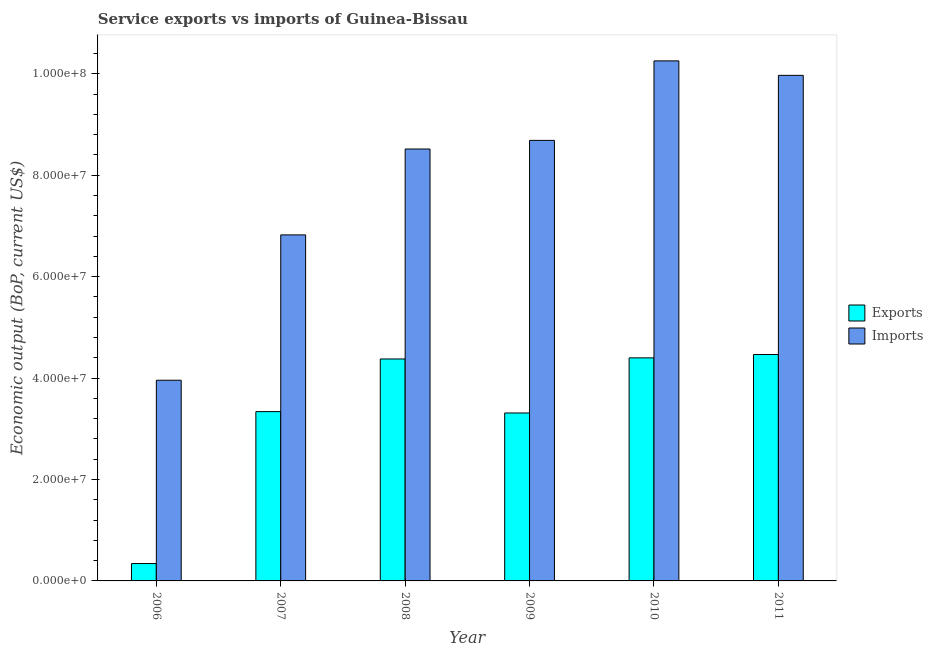How many different coloured bars are there?
Provide a short and direct response. 2. Are the number of bars per tick equal to the number of legend labels?
Ensure brevity in your answer.  Yes. Are the number of bars on each tick of the X-axis equal?
Provide a short and direct response. Yes. How many bars are there on the 5th tick from the left?
Make the answer very short. 2. What is the label of the 4th group of bars from the left?
Ensure brevity in your answer.  2009. In how many cases, is the number of bars for a given year not equal to the number of legend labels?
Your answer should be very brief. 0. What is the amount of service imports in 2008?
Offer a terse response. 8.52e+07. Across all years, what is the maximum amount of service exports?
Provide a short and direct response. 4.46e+07. Across all years, what is the minimum amount of service imports?
Give a very brief answer. 3.96e+07. In which year was the amount of service exports maximum?
Give a very brief answer. 2011. What is the total amount of service exports in the graph?
Offer a terse response. 2.02e+08. What is the difference between the amount of service exports in 2007 and that in 2011?
Offer a terse response. -1.13e+07. What is the difference between the amount of service exports in 2008 and the amount of service imports in 2007?
Your answer should be compact. 1.04e+07. What is the average amount of service imports per year?
Offer a terse response. 8.04e+07. What is the ratio of the amount of service imports in 2007 to that in 2010?
Give a very brief answer. 0.67. Is the amount of service imports in 2006 less than that in 2007?
Make the answer very short. Yes. What is the difference between the highest and the second highest amount of service imports?
Offer a very short reply. 2.86e+06. What is the difference between the highest and the lowest amount of service exports?
Your answer should be very brief. 4.12e+07. In how many years, is the amount of service exports greater than the average amount of service exports taken over all years?
Your answer should be very brief. 3. What does the 1st bar from the left in 2006 represents?
Offer a very short reply. Exports. What does the 1st bar from the right in 2009 represents?
Provide a short and direct response. Imports. Are all the bars in the graph horizontal?
Keep it short and to the point. No. What is the difference between two consecutive major ticks on the Y-axis?
Give a very brief answer. 2.00e+07. Does the graph contain any zero values?
Your response must be concise. No. How many legend labels are there?
Offer a terse response. 2. How are the legend labels stacked?
Your answer should be compact. Vertical. What is the title of the graph?
Provide a short and direct response. Service exports vs imports of Guinea-Bissau. What is the label or title of the X-axis?
Keep it short and to the point. Year. What is the label or title of the Y-axis?
Make the answer very short. Economic output (BoP, current US$). What is the Economic output (BoP, current US$) in Exports in 2006?
Your answer should be compact. 3.43e+06. What is the Economic output (BoP, current US$) of Imports in 2006?
Offer a very short reply. 3.96e+07. What is the Economic output (BoP, current US$) of Exports in 2007?
Your response must be concise. 3.34e+07. What is the Economic output (BoP, current US$) of Imports in 2007?
Ensure brevity in your answer.  6.82e+07. What is the Economic output (BoP, current US$) of Exports in 2008?
Make the answer very short. 4.38e+07. What is the Economic output (BoP, current US$) of Imports in 2008?
Provide a short and direct response. 8.52e+07. What is the Economic output (BoP, current US$) in Exports in 2009?
Your response must be concise. 3.31e+07. What is the Economic output (BoP, current US$) in Imports in 2009?
Make the answer very short. 8.69e+07. What is the Economic output (BoP, current US$) in Exports in 2010?
Offer a very short reply. 4.40e+07. What is the Economic output (BoP, current US$) of Imports in 2010?
Provide a succinct answer. 1.03e+08. What is the Economic output (BoP, current US$) of Exports in 2011?
Give a very brief answer. 4.46e+07. What is the Economic output (BoP, current US$) in Imports in 2011?
Offer a terse response. 9.97e+07. Across all years, what is the maximum Economic output (BoP, current US$) in Exports?
Give a very brief answer. 4.46e+07. Across all years, what is the maximum Economic output (BoP, current US$) in Imports?
Your response must be concise. 1.03e+08. Across all years, what is the minimum Economic output (BoP, current US$) in Exports?
Keep it short and to the point. 3.43e+06. Across all years, what is the minimum Economic output (BoP, current US$) of Imports?
Make the answer very short. 3.96e+07. What is the total Economic output (BoP, current US$) of Exports in the graph?
Your answer should be compact. 2.02e+08. What is the total Economic output (BoP, current US$) in Imports in the graph?
Your answer should be compact. 4.82e+08. What is the difference between the Economic output (BoP, current US$) of Exports in 2006 and that in 2007?
Your response must be concise. -3.00e+07. What is the difference between the Economic output (BoP, current US$) of Imports in 2006 and that in 2007?
Offer a terse response. -2.87e+07. What is the difference between the Economic output (BoP, current US$) in Exports in 2006 and that in 2008?
Offer a very short reply. -4.03e+07. What is the difference between the Economic output (BoP, current US$) in Imports in 2006 and that in 2008?
Ensure brevity in your answer.  -4.56e+07. What is the difference between the Economic output (BoP, current US$) in Exports in 2006 and that in 2009?
Your answer should be compact. -2.97e+07. What is the difference between the Economic output (BoP, current US$) in Imports in 2006 and that in 2009?
Ensure brevity in your answer.  -4.73e+07. What is the difference between the Economic output (BoP, current US$) in Exports in 2006 and that in 2010?
Provide a succinct answer. -4.06e+07. What is the difference between the Economic output (BoP, current US$) of Imports in 2006 and that in 2010?
Make the answer very short. -6.30e+07. What is the difference between the Economic output (BoP, current US$) in Exports in 2006 and that in 2011?
Offer a very short reply. -4.12e+07. What is the difference between the Economic output (BoP, current US$) of Imports in 2006 and that in 2011?
Give a very brief answer. -6.01e+07. What is the difference between the Economic output (BoP, current US$) of Exports in 2007 and that in 2008?
Offer a terse response. -1.04e+07. What is the difference between the Economic output (BoP, current US$) in Imports in 2007 and that in 2008?
Offer a very short reply. -1.69e+07. What is the difference between the Economic output (BoP, current US$) in Exports in 2007 and that in 2009?
Your answer should be compact. 2.70e+05. What is the difference between the Economic output (BoP, current US$) in Imports in 2007 and that in 2009?
Offer a terse response. -1.86e+07. What is the difference between the Economic output (BoP, current US$) in Exports in 2007 and that in 2010?
Ensure brevity in your answer.  -1.06e+07. What is the difference between the Economic output (BoP, current US$) in Imports in 2007 and that in 2010?
Your answer should be very brief. -3.43e+07. What is the difference between the Economic output (BoP, current US$) in Exports in 2007 and that in 2011?
Offer a terse response. -1.13e+07. What is the difference between the Economic output (BoP, current US$) of Imports in 2007 and that in 2011?
Offer a very short reply. -3.15e+07. What is the difference between the Economic output (BoP, current US$) in Exports in 2008 and that in 2009?
Offer a very short reply. 1.07e+07. What is the difference between the Economic output (BoP, current US$) in Imports in 2008 and that in 2009?
Ensure brevity in your answer.  -1.70e+06. What is the difference between the Economic output (BoP, current US$) in Exports in 2008 and that in 2010?
Your answer should be compact. -2.20e+05. What is the difference between the Economic output (BoP, current US$) of Imports in 2008 and that in 2010?
Offer a terse response. -1.74e+07. What is the difference between the Economic output (BoP, current US$) of Exports in 2008 and that in 2011?
Offer a very short reply. -8.79e+05. What is the difference between the Economic output (BoP, current US$) of Imports in 2008 and that in 2011?
Provide a succinct answer. -1.45e+07. What is the difference between the Economic output (BoP, current US$) of Exports in 2009 and that in 2010?
Provide a succinct answer. -1.09e+07. What is the difference between the Economic output (BoP, current US$) in Imports in 2009 and that in 2010?
Make the answer very short. -1.57e+07. What is the difference between the Economic output (BoP, current US$) of Exports in 2009 and that in 2011?
Provide a short and direct response. -1.15e+07. What is the difference between the Economic output (BoP, current US$) of Imports in 2009 and that in 2011?
Your response must be concise. -1.28e+07. What is the difference between the Economic output (BoP, current US$) of Exports in 2010 and that in 2011?
Give a very brief answer. -6.59e+05. What is the difference between the Economic output (BoP, current US$) of Imports in 2010 and that in 2011?
Ensure brevity in your answer.  2.86e+06. What is the difference between the Economic output (BoP, current US$) of Exports in 2006 and the Economic output (BoP, current US$) of Imports in 2007?
Make the answer very short. -6.48e+07. What is the difference between the Economic output (BoP, current US$) of Exports in 2006 and the Economic output (BoP, current US$) of Imports in 2008?
Your answer should be very brief. -8.18e+07. What is the difference between the Economic output (BoP, current US$) of Exports in 2006 and the Economic output (BoP, current US$) of Imports in 2009?
Your response must be concise. -8.35e+07. What is the difference between the Economic output (BoP, current US$) of Exports in 2006 and the Economic output (BoP, current US$) of Imports in 2010?
Offer a very short reply. -9.91e+07. What is the difference between the Economic output (BoP, current US$) in Exports in 2006 and the Economic output (BoP, current US$) in Imports in 2011?
Offer a terse response. -9.63e+07. What is the difference between the Economic output (BoP, current US$) in Exports in 2007 and the Economic output (BoP, current US$) in Imports in 2008?
Offer a very short reply. -5.18e+07. What is the difference between the Economic output (BoP, current US$) in Exports in 2007 and the Economic output (BoP, current US$) in Imports in 2009?
Your response must be concise. -5.35e+07. What is the difference between the Economic output (BoP, current US$) in Exports in 2007 and the Economic output (BoP, current US$) in Imports in 2010?
Provide a short and direct response. -6.92e+07. What is the difference between the Economic output (BoP, current US$) in Exports in 2007 and the Economic output (BoP, current US$) in Imports in 2011?
Make the answer very short. -6.63e+07. What is the difference between the Economic output (BoP, current US$) of Exports in 2008 and the Economic output (BoP, current US$) of Imports in 2009?
Offer a very short reply. -4.31e+07. What is the difference between the Economic output (BoP, current US$) of Exports in 2008 and the Economic output (BoP, current US$) of Imports in 2010?
Provide a succinct answer. -5.88e+07. What is the difference between the Economic output (BoP, current US$) of Exports in 2008 and the Economic output (BoP, current US$) of Imports in 2011?
Offer a very short reply. -5.59e+07. What is the difference between the Economic output (BoP, current US$) in Exports in 2009 and the Economic output (BoP, current US$) in Imports in 2010?
Your answer should be very brief. -6.94e+07. What is the difference between the Economic output (BoP, current US$) of Exports in 2009 and the Economic output (BoP, current US$) of Imports in 2011?
Your answer should be compact. -6.66e+07. What is the difference between the Economic output (BoP, current US$) in Exports in 2010 and the Economic output (BoP, current US$) in Imports in 2011?
Your answer should be compact. -5.57e+07. What is the average Economic output (BoP, current US$) of Exports per year?
Offer a very short reply. 3.37e+07. What is the average Economic output (BoP, current US$) of Imports per year?
Provide a succinct answer. 8.04e+07. In the year 2006, what is the difference between the Economic output (BoP, current US$) in Exports and Economic output (BoP, current US$) in Imports?
Ensure brevity in your answer.  -3.62e+07. In the year 2007, what is the difference between the Economic output (BoP, current US$) in Exports and Economic output (BoP, current US$) in Imports?
Your response must be concise. -3.49e+07. In the year 2008, what is the difference between the Economic output (BoP, current US$) of Exports and Economic output (BoP, current US$) of Imports?
Keep it short and to the point. -4.14e+07. In the year 2009, what is the difference between the Economic output (BoP, current US$) of Exports and Economic output (BoP, current US$) of Imports?
Offer a very short reply. -5.38e+07. In the year 2010, what is the difference between the Economic output (BoP, current US$) of Exports and Economic output (BoP, current US$) of Imports?
Offer a very short reply. -5.86e+07. In the year 2011, what is the difference between the Economic output (BoP, current US$) in Exports and Economic output (BoP, current US$) in Imports?
Offer a terse response. -5.51e+07. What is the ratio of the Economic output (BoP, current US$) in Exports in 2006 to that in 2007?
Your answer should be compact. 0.1. What is the ratio of the Economic output (BoP, current US$) of Imports in 2006 to that in 2007?
Ensure brevity in your answer.  0.58. What is the ratio of the Economic output (BoP, current US$) in Exports in 2006 to that in 2008?
Provide a succinct answer. 0.08. What is the ratio of the Economic output (BoP, current US$) of Imports in 2006 to that in 2008?
Provide a short and direct response. 0.46. What is the ratio of the Economic output (BoP, current US$) in Exports in 2006 to that in 2009?
Offer a terse response. 0.1. What is the ratio of the Economic output (BoP, current US$) of Imports in 2006 to that in 2009?
Provide a short and direct response. 0.46. What is the ratio of the Economic output (BoP, current US$) of Exports in 2006 to that in 2010?
Provide a succinct answer. 0.08. What is the ratio of the Economic output (BoP, current US$) in Imports in 2006 to that in 2010?
Your answer should be compact. 0.39. What is the ratio of the Economic output (BoP, current US$) in Exports in 2006 to that in 2011?
Provide a succinct answer. 0.08. What is the ratio of the Economic output (BoP, current US$) of Imports in 2006 to that in 2011?
Your answer should be compact. 0.4. What is the ratio of the Economic output (BoP, current US$) in Exports in 2007 to that in 2008?
Offer a very short reply. 0.76. What is the ratio of the Economic output (BoP, current US$) of Imports in 2007 to that in 2008?
Your answer should be compact. 0.8. What is the ratio of the Economic output (BoP, current US$) of Exports in 2007 to that in 2009?
Provide a succinct answer. 1.01. What is the ratio of the Economic output (BoP, current US$) of Imports in 2007 to that in 2009?
Give a very brief answer. 0.79. What is the ratio of the Economic output (BoP, current US$) of Exports in 2007 to that in 2010?
Provide a succinct answer. 0.76. What is the ratio of the Economic output (BoP, current US$) of Imports in 2007 to that in 2010?
Keep it short and to the point. 0.67. What is the ratio of the Economic output (BoP, current US$) of Exports in 2007 to that in 2011?
Ensure brevity in your answer.  0.75. What is the ratio of the Economic output (BoP, current US$) in Imports in 2007 to that in 2011?
Make the answer very short. 0.68. What is the ratio of the Economic output (BoP, current US$) of Exports in 2008 to that in 2009?
Give a very brief answer. 1.32. What is the ratio of the Economic output (BoP, current US$) of Imports in 2008 to that in 2009?
Provide a short and direct response. 0.98. What is the ratio of the Economic output (BoP, current US$) in Exports in 2008 to that in 2010?
Offer a terse response. 0.99. What is the ratio of the Economic output (BoP, current US$) in Imports in 2008 to that in 2010?
Provide a succinct answer. 0.83. What is the ratio of the Economic output (BoP, current US$) of Exports in 2008 to that in 2011?
Offer a terse response. 0.98. What is the ratio of the Economic output (BoP, current US$) in Imports in 2008 to that in 2011?
Offer a very short reply. 0.85. What is the ratio of the Economic output (BoP, current US$) in Exports in 2009 to that in 2010?
Make the answer very short. 0.75. What is the ratio of the Economic output (BoP, current US$) in Imports in 2009 to that in 2010?
Your response must be concise. 0.85. What is the ratio of the Economic output (BoP, current US$) in Exports in 2009 to that in 2011?
Offer a very short reply. 0.74. What is the ratio of the Economic output (BoP, current US$) in Imports in 2009 to that in 2011?
Ensure brevity in your answer.  0.87. What is the ratio of the Economic output (BoP, current US$) in Exports in 2010 to that in 2011?
Offer a terse response. 0.99. What is the ratio of the Economic output (BoP, current US$) in Imports in 2010 to that in 2011?
Your response must be concise. 1.03. What is the difference between the highest and the second highest Economic output (BoP, current US$) in Exports?
Make the answer very short. 6.59e+05. What is the difference between the highest and the second highest Economic output (BoP, current US$) in Imports?
Your response must be concise. 2.86e+06. What is the difference between the highest and the lowest Economic output (BoP, current US$) in Exports?
Your response must be concise. 4.12e+07. What is the difference between the highest and the lowest Economic output (BoP, current US$) of Imports?
Your answer should be very brief. 6.30e+07. 